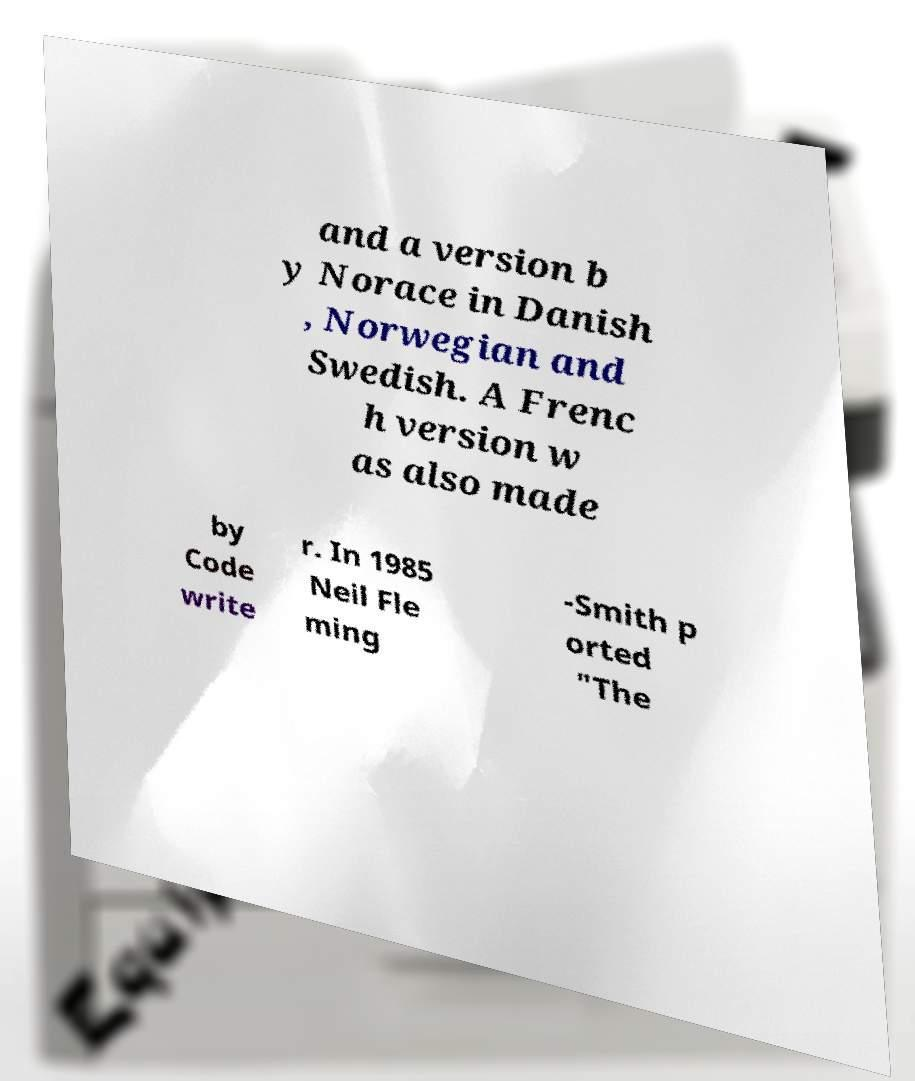Please identify and transcribe the text found in this image. and a version b y Norace in Danish , Norwegian and Swedish. A Frenc h version w as also made by Code write r. In 1985 Neil Fle ming -Smith p orted "The 